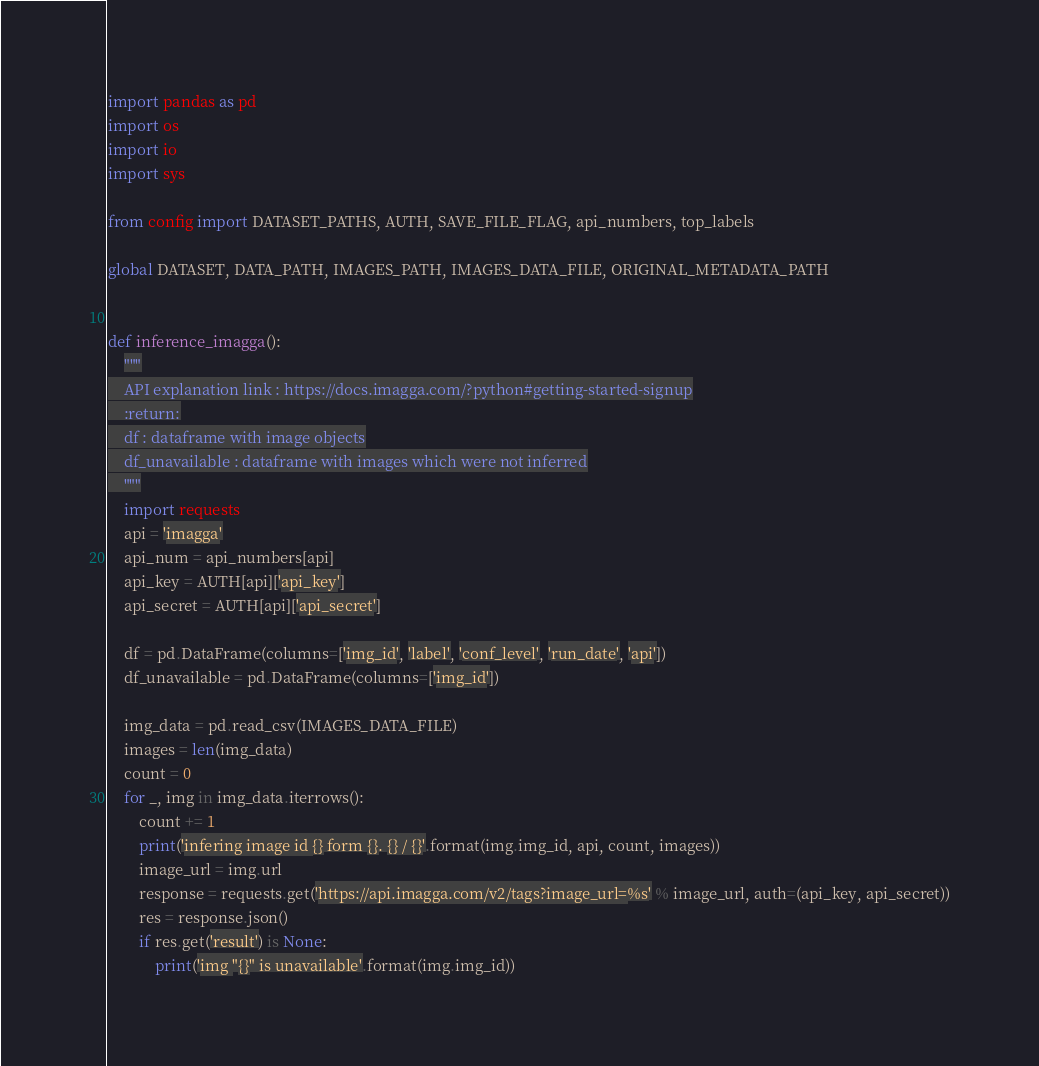<code> <loc_0><loc_0><loc_500><loc_500><_Python_>
import pandas as pd
import os
import io
import sys

from config import DATASET_PATHS, AUTH, SAVE_FILE_FLAG, api_numbers, top_labels

global DATASET, DATA_PATH, IMAGES_PATH, IMAGES_DATA_FILE, ORIGINAL_METADATA_PATH


def inference_imagga():
    """
    API explanation link : https://docs.imagga.com/?python#getting-started-signup
    :return:
    df : dataframe with image objects
    df_unavailable : dataframe with images which were not inferred
    """
    import requests
    api = 'imagga'
    api_num = api_numbers[api]
    api_key = AUTH[api]['api_key']
    api_secret = AUTH[api]['api_secret']

    df = pd.DataFrame(columns=['img_id', 'label', 'conf_level', 'run_date', 'api'])
    df_unavailable = pd.DataFrame(columns=['img_id'])

    img_data = pd.read_csv(IMAGES_DATA_FILE)
    images = len(img_data)
    count = 0
    for _, img in img_data.iterrows():
        count += 1
        print('infering image id {} form {}. {} / {}'.format(img.img_id, api, count, images))
        image_url = img.url
        response = requests.get('https://api.imagga.com/v2/tags?image_url=%s' % image_url, auth=(api_key, api_secret))
        res = response.json()
        if res.get('result') is None:
            print('img "{}" is unavailable'.format(img.img_id))</code> 